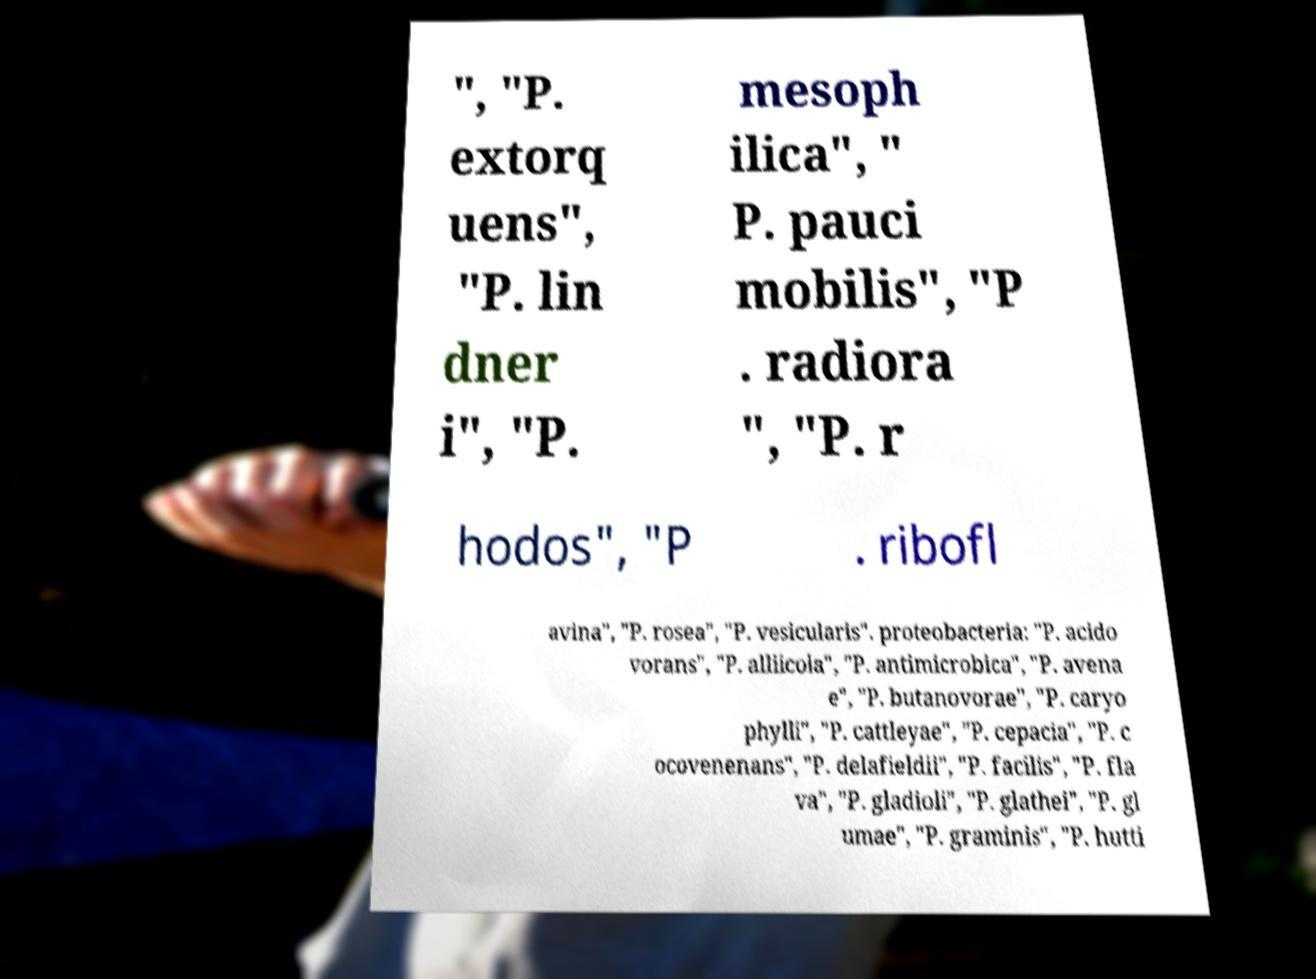There's text embedded in this image that I need extracted. Can you transcribe it verbatim? ", "P. extorq uens", "P. lin dner i", "P. mesoph ilica", " P. pauci mobilis", "P . radiora ", "P. r hodos", "P . ribofl avina", "P. rosea", "P. vesicularis". proteobacteria: "P. acido vorans", "P. alliicola", "P. antimicrobica", "P. avena e", "P. butanovorae", "P. caryo phylli", "P. cattleyae", "P. cepacia", "P. c ocovenenans", "P. delafieldii", "P. facilis", "P. fla va", "P. gladioli", "P. glathei", "P. gl umae", "P. graminis", "P. hutti 